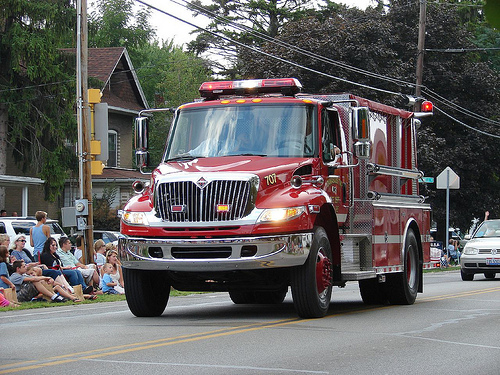<image>
Is the human in the truck? No. The human is not contained within the truck. These objects have a different spatial relationship. 